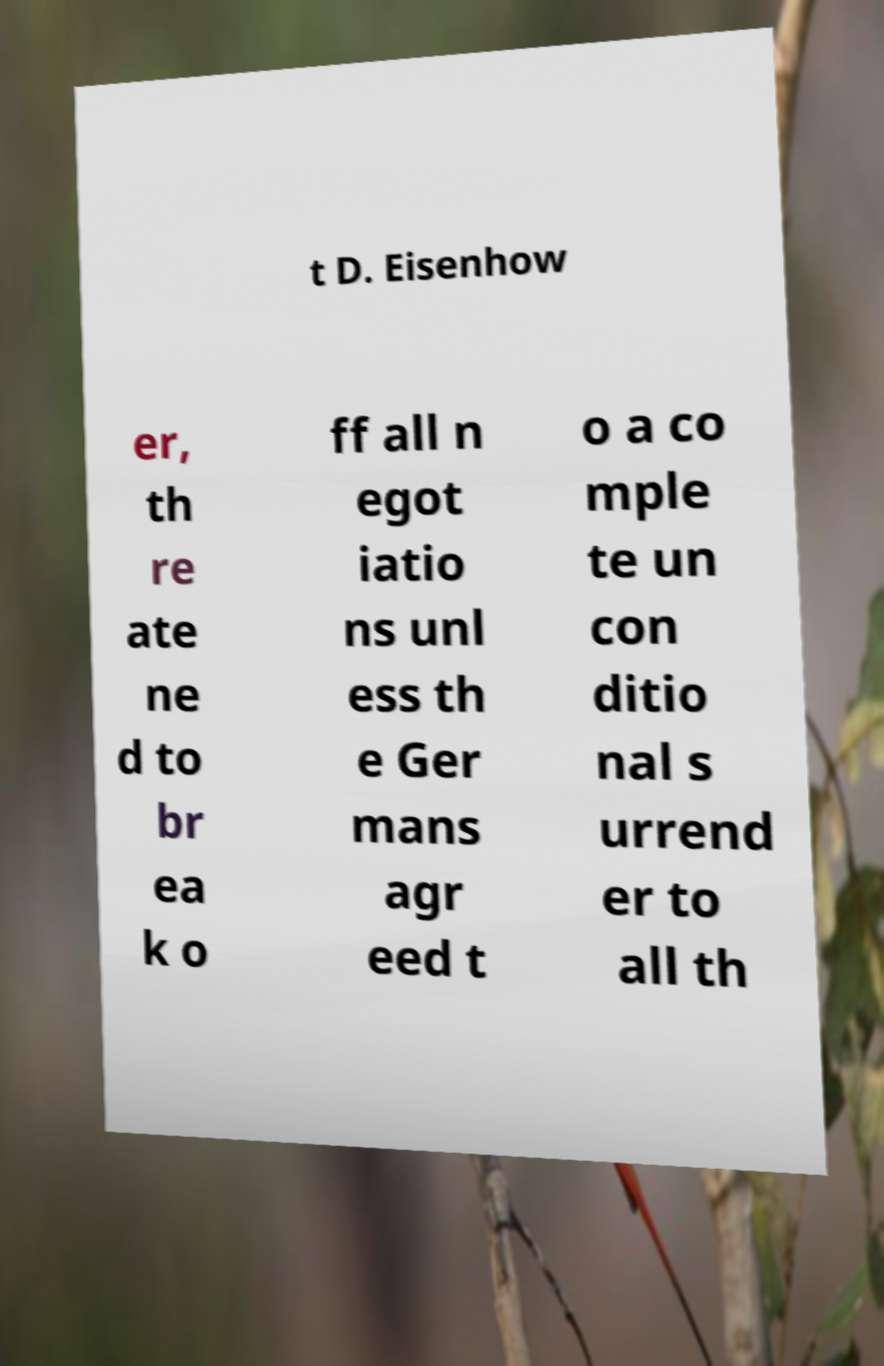Can you accurately transcribe the text from the provided image for me? t D. Eisenhow er, th re ate ne d to br ea k o ff all n egot iatio ns unl ess th e Ger mans agr eed t o a co mple te un con ditio nal s urrend er to all th 